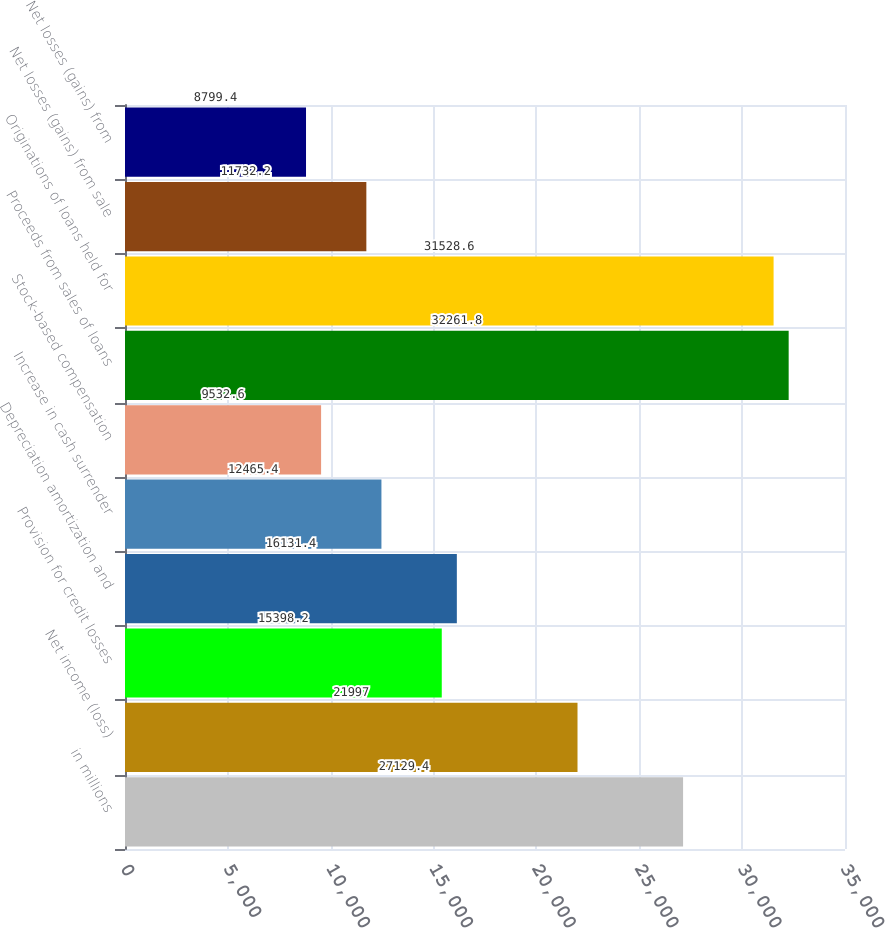<chart> <loc_0><loc_0><loc_500><loc_500><bar_chart><fcel>in millions<fcel>Net income (loss)<fcel>Provision for credit losses<fcel>Depreciation amortization and<fcel>Increase in cash surrender<fcel>Stock-based compensation<fcel>Proceeds from sales of loans<fcel>Originations of loans held for<fcel>Net losses (gains) from sale<fcel>Net losses (gains) from<nl><fcel>27129.4<fcel>21997<fcel>15398.2<fcel>16131.4<fcel>12465.4<fcel>9532.6<fcel>32261.8<fcel>31528.6<fcel>11732.2<fcel>8799.4<nl></chart> 